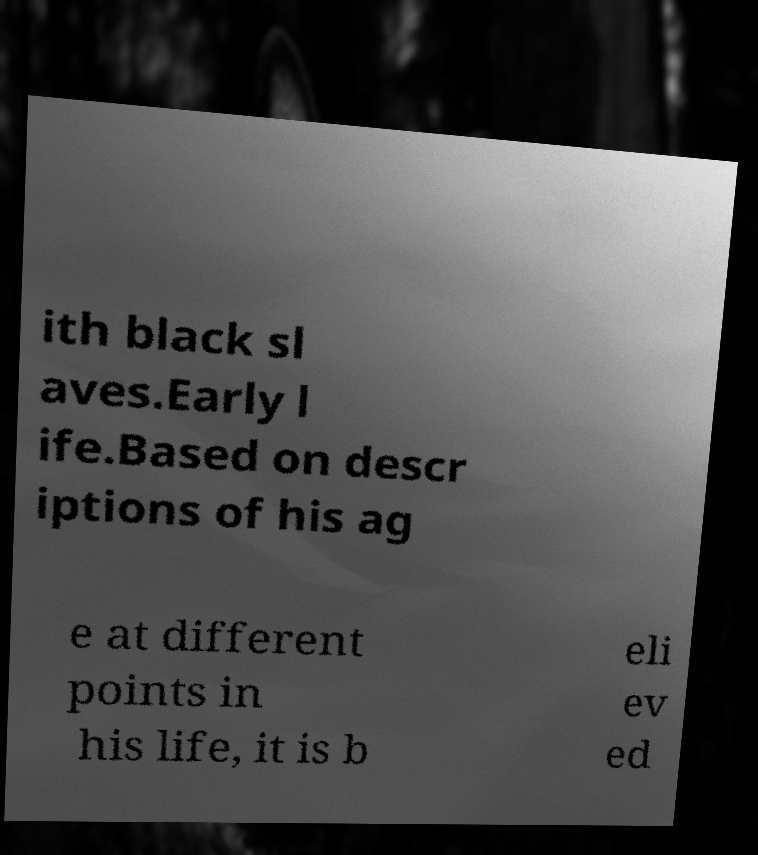Could you extract and type out the text from this image? ith black sl aves.Early l ife.Based on descr iptions of his ag e at different points in his life, it is b eli ev ed 